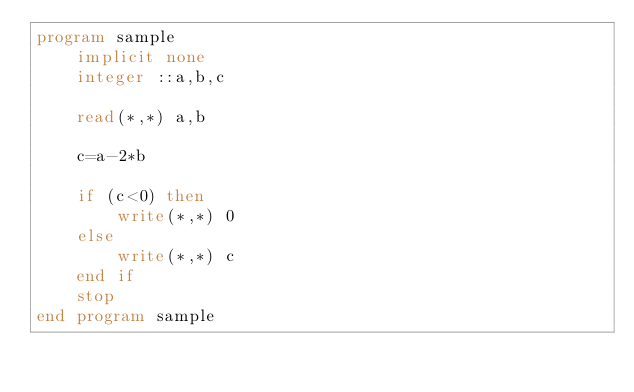Convert code to text. <code><loc_0><loc_0><loc_500><loc_500><_FORTRAN_>program sample
	implicit none
    integer ::a,b,c
    
    read(*,*) a,b
    
    c=a-2*b
    
    if (c<0) then
    	write(*,*) 0
    else
    	write(*,*) c
    end if
    stop
end program sample

</code> 